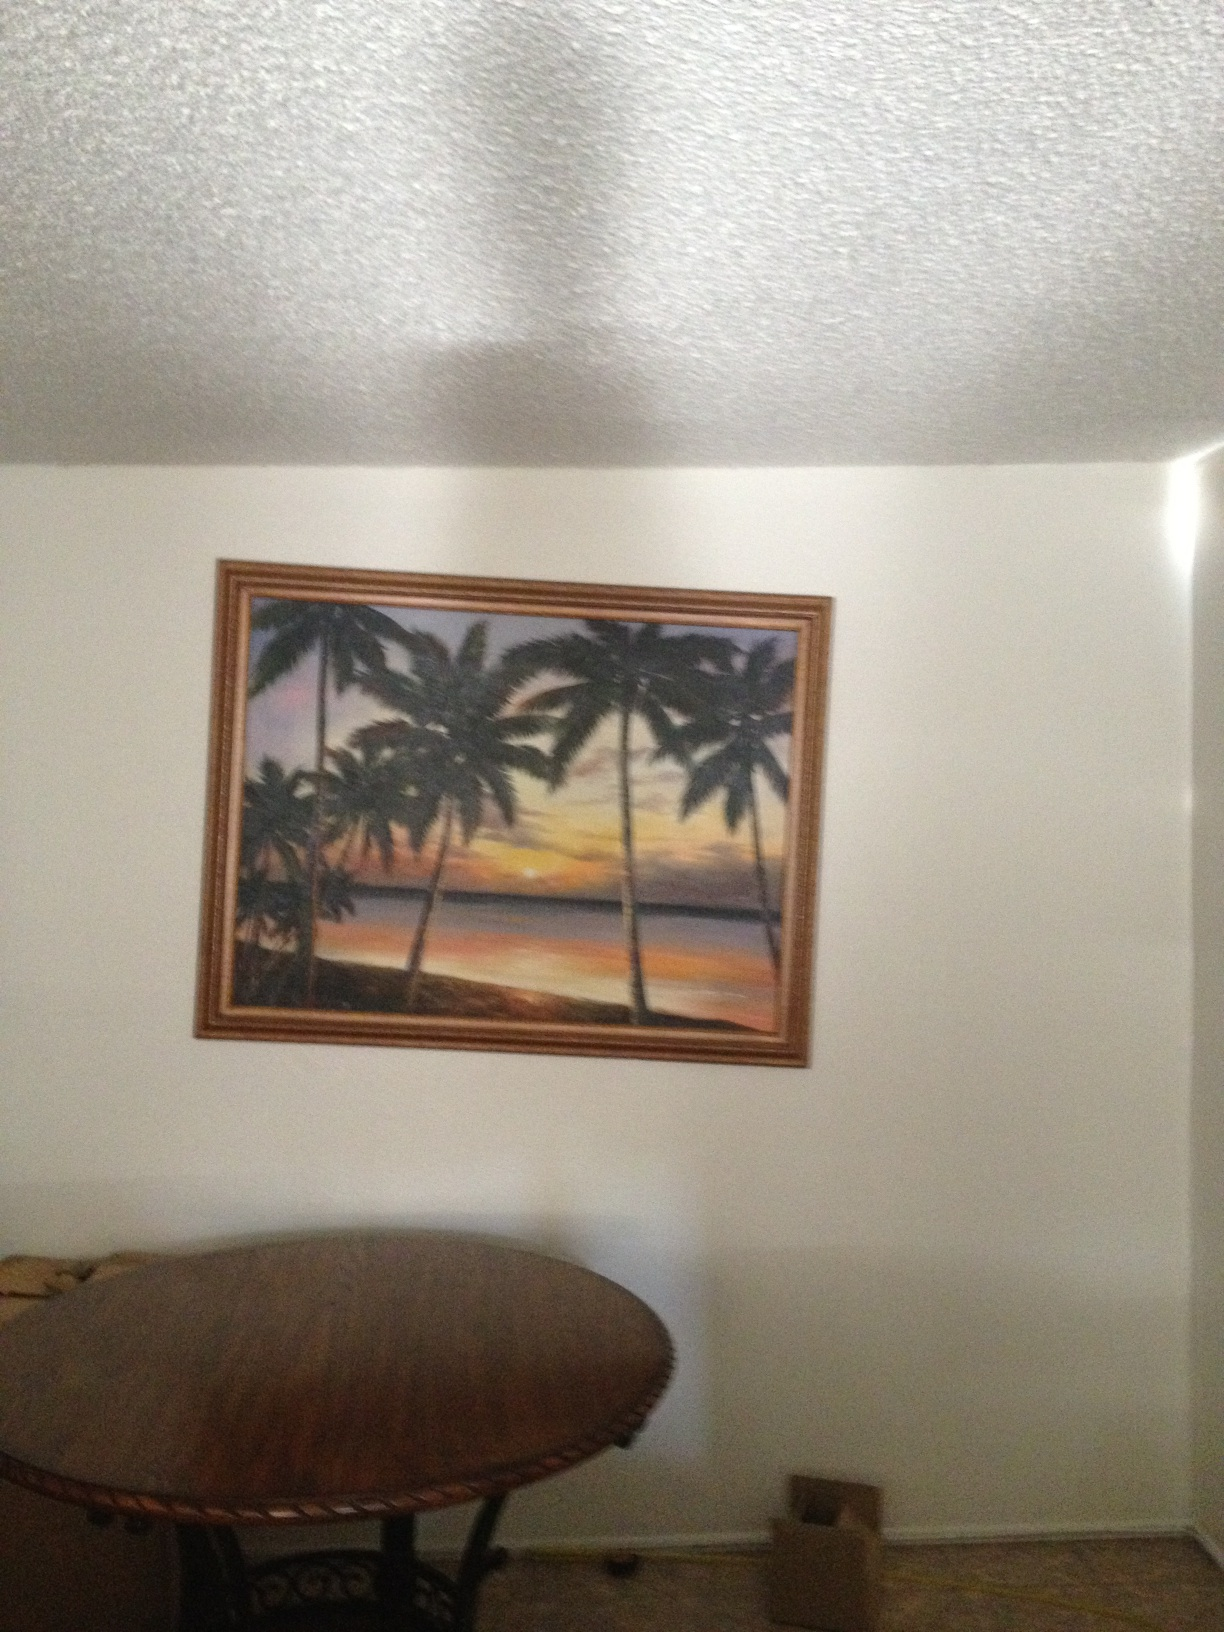Can you describe the types of trees shown in this painting and their significance in the context? These are palm trees, commonly found in tropical and subtropical regions. Their presence in the painting emphasizes a coastal or island setting, often symbolizing a paradise-like environment, relaxation, and vacation vibes. 